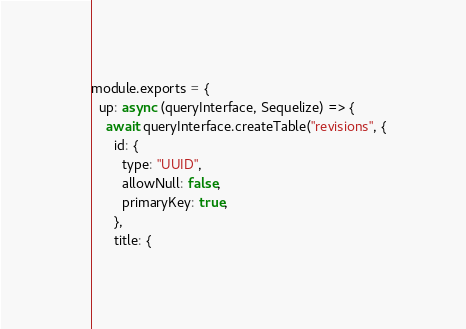Convert code to text. <code><loc_0><loc_0><loc_500><loc_500><_JavaScript_>module.exports = {
  up: async (queryInterface, Sequelize) => {
    await queryInterface.createTable("revisions", {
      id: {
        type: "UUID",
        allowNull: false,
        primaryKey: true,
      },
      title: {</code> 